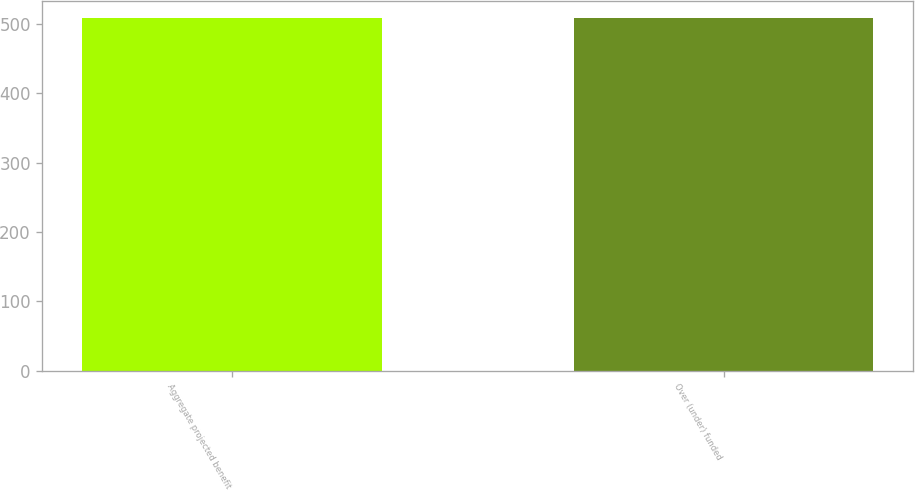Convert chart. <chart><loc_0><loc_0><loc_500><loc_500><bar_chart><fcel>Aggregate projected benefit<fcel>Over (under) funded<nl><fcel>508<fcel>508.1<nl></chart> 